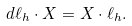<formula> <loc_0><loc_0><loc_500><loc_500>d \ell _ { h } \cdot X = X \cdot \ell _ { h } .</formula> 